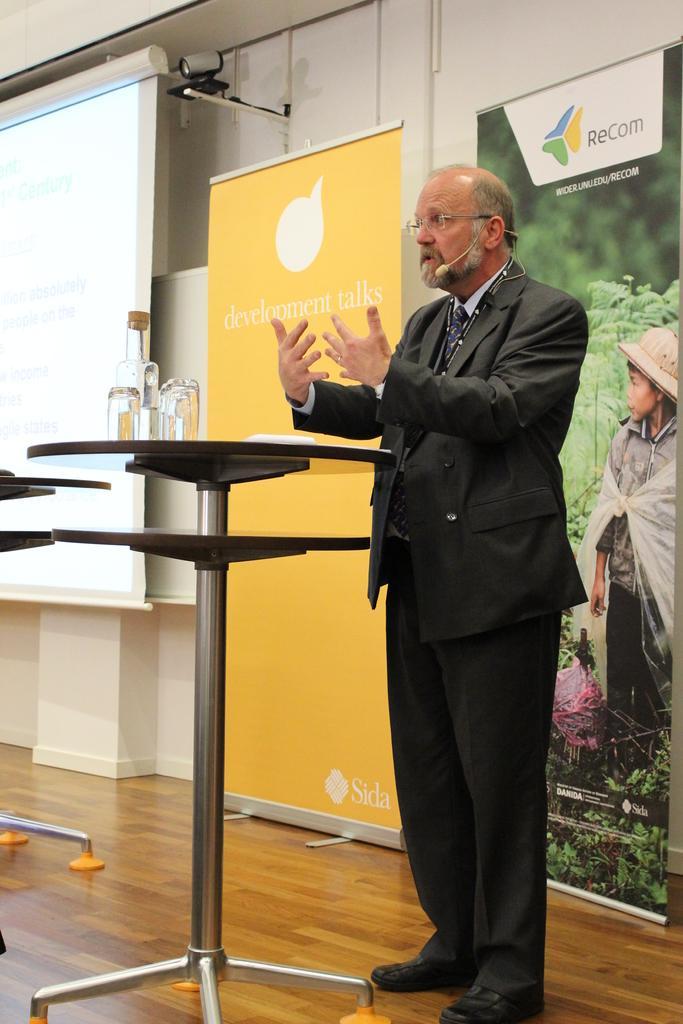Could you give a brief overview of what you see in this image? As we can see in the image there is a white color wall, screen, cc camera, banner and a man wearing mic and standing over here. 